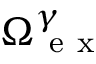Convert formula to latex. <formula><loc_0><loc_0><loc_500><loc_500>{ \Omega } _ { e x } ^ { \gamma }</formula> 